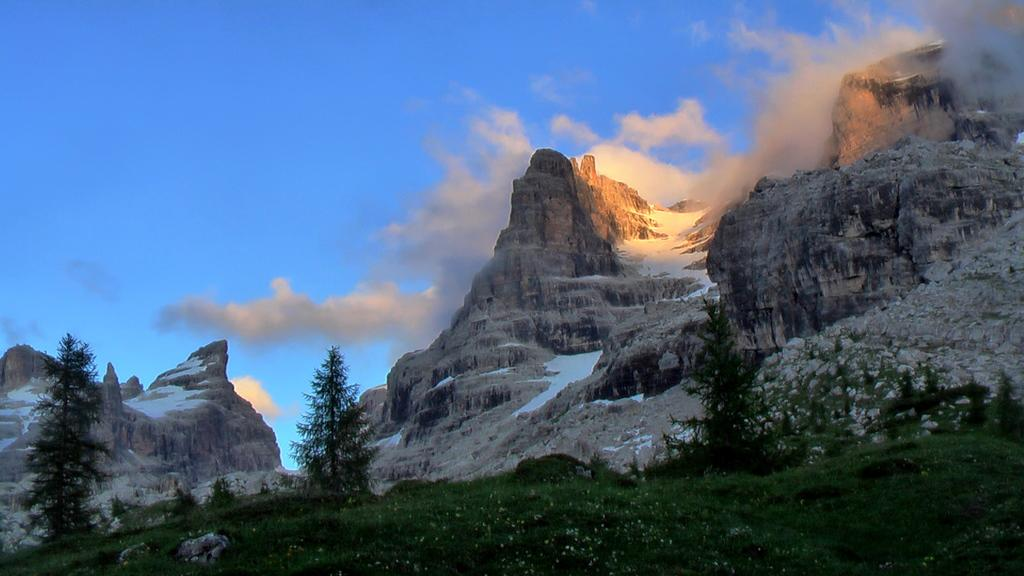What type of vegetation is present in the image? There are trees in the image. What is covering the ground at the bottom of the image? There is grass on the surface at the bottom of the image. What is covering the rocks in the image? There is snow on the rocks. What is visible in the sky at the top of the image? There are clouds in the sky at the top of the image. Where is the train located in the image? There is no train present in the image. What type of waste is visible in the image? There is no waste visible in the image. 